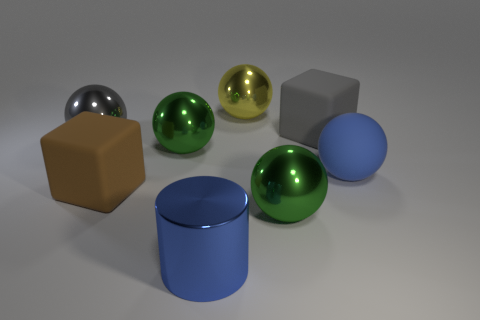Add 1 rubber things. How many objects exist? 9 Subtract all green metal balls. How many balls are left? 3 Subtract all purple cylinders. How many green spheres are left? 2 Subtract 3 spheres. How many spheres are left? 2 Subtract all blocks. How many objects are left? 6 Subtract all brown cubes. How many cubes are left? 1 Subtract 0 brown spheres. How many objects are left? 8 Subtract all blue balls. Subtract all purple cylinders. How many balls are left? 4 Subtract all blue cylinders. Subtract all big gray rubber blocks. How many objects are left? 6 Add 1 big green metal balls. How many big green metal balls are left? 3 